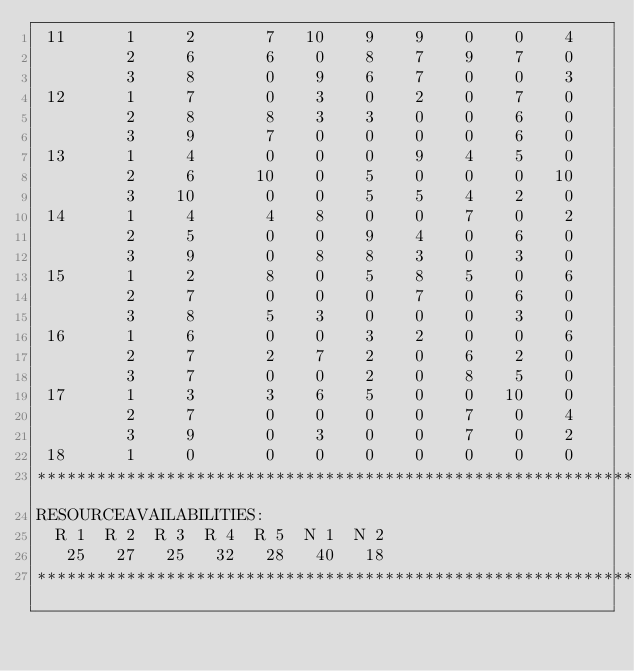Convert code to text. <code><loc_0><loc_0><loc_500><loc_500><_ObjectiveC_> 11      1     2       7   10    9    9    0    0    4
         2     6       6    0    8    7    9    7    0
         3     8       0    9    6    7    0    0    3
 12      1     7       0    3    0    2    0    7    0
         2     8       8    3    3    0    0    6    0
         3     9       7    0    0    0    0    6    0
 13      1     4       0    0    0    9    4    5    0
         2     6      10    0    5    0    0    0   10
         3    10       0    0    5    5    4    2    0
 14      1     4       4    8    0    0    7    0    2
         2     5       0    0    9    4    0    6    0
         3     9       0    8    8    3    0    3    0
 15      1     2       8    0    5    8    5    0    6
         2     7       0    0    0    7    0    6    0
         3     8       5    3    0    0    0    3    0
 16      1     6       0    0    3    2    0    0    6
         2     7       2    7    2    0    6    2    0
         3     7       0    0    2    0    8    5    0
 17      1     3       3    6    5    0    0   10    0
         2     7       0    0    0    0    7    0    4
         3     9       0    3    0    0    7    0    2
 18      1     0       0    0    0    0    0    0    0
************************************************************************
RESOURCEAVAILABILITIES:
  R 1  R 2  R 3  R 4  R 5  N 1  N 2
   25   27   25   32   28   40   18
************************************************************************
</code> 